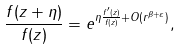Convert formula to latex. <formula><loc_0><loc_0><loc_500><loc_500>\frac { f ( z + \eta ) } { f ( z ) } = e ^ { \eta \frac { f ^ { \prime } ( z ) } { f ( z ) } + O ( r ^ { \beta + \varepsilon } ) } ,</formula> 